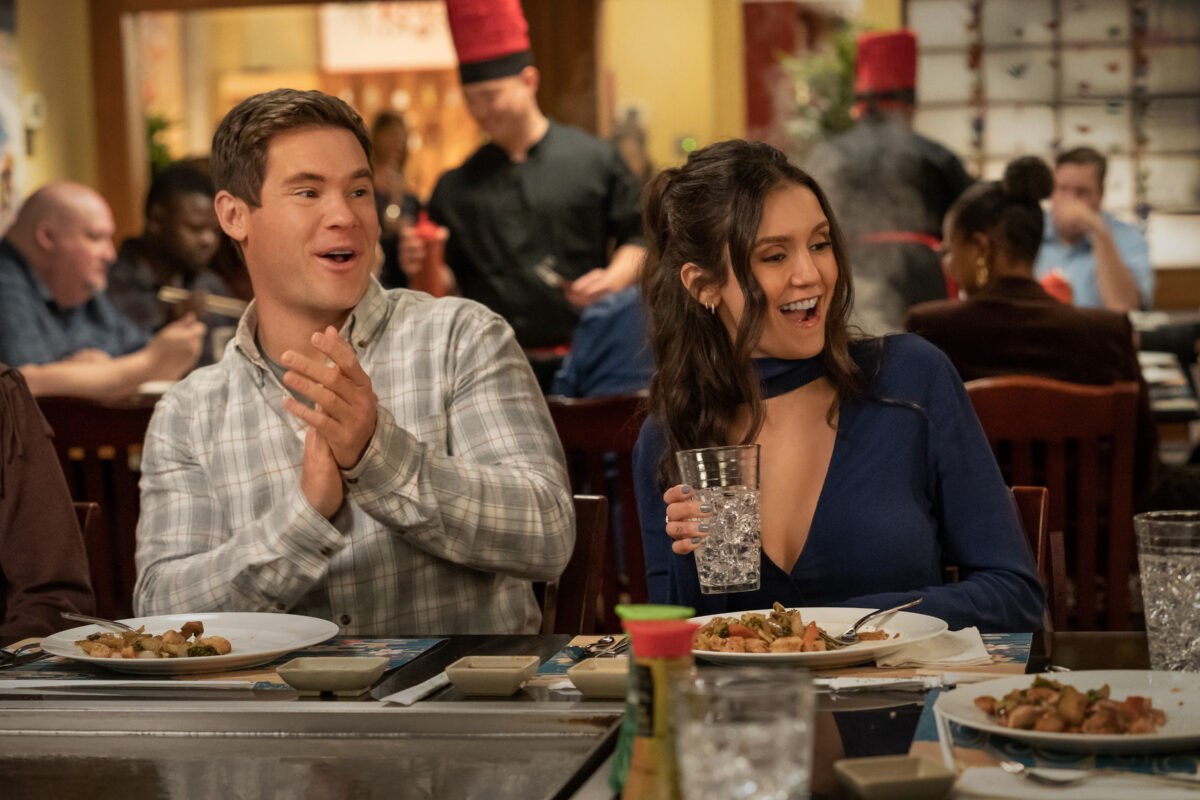What's happening on this image? In this image, taken from the movie 'Isn't It Romantic', we see two characters, played by Nina Dobrev and Adam Devine, enjoying a lively dining experience. Both are seated at a restaurant table filled with assorted dishes. Nina, dressed in an elegant blue top, holds a glass filled with what appears to be water or a clear beverage, her face lit with a broad, joyful smile. Sitting beside her, Adam is caught in the middle of a cheerful clap, adding a sense of excitement and fun to the scene. The background is bustling with other diners and restaurant staff, which adds to the lively and vibrant atmosphere. What kind of restaurant are they in, and what might they be celebrating? The setting appears to be a vibrant and lively restaurant, possibly a Japanese teppanyaki or another similar type of eatery where chefs cook in front of the guests. The decor and the chef in the background, identifiable by his iconic red hat, support this. As for what they might be celebrating, given the celebratory gestures and happy expressions, it could be a special occasion such as a birthday, anniversary, or possibly a professional success or milestone reached by one of the characters. 